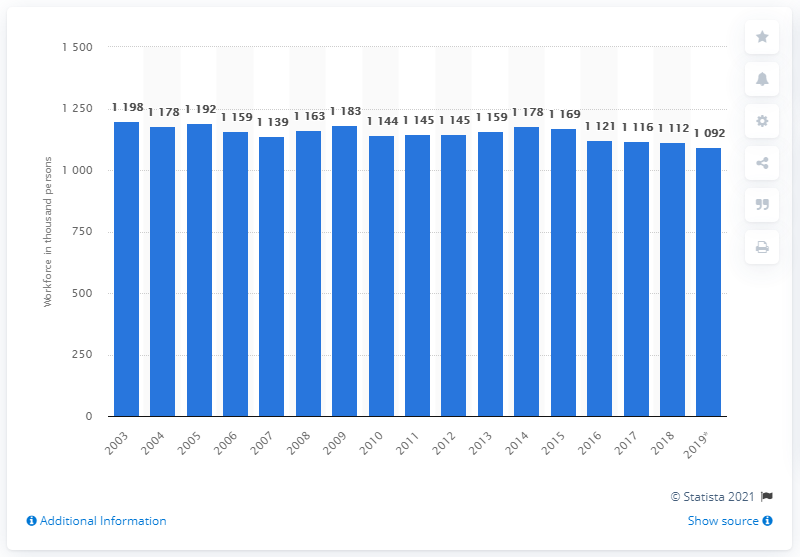List a handful of essential elements in this visual. In 2014, the food retail sector employed 1,169 people. 